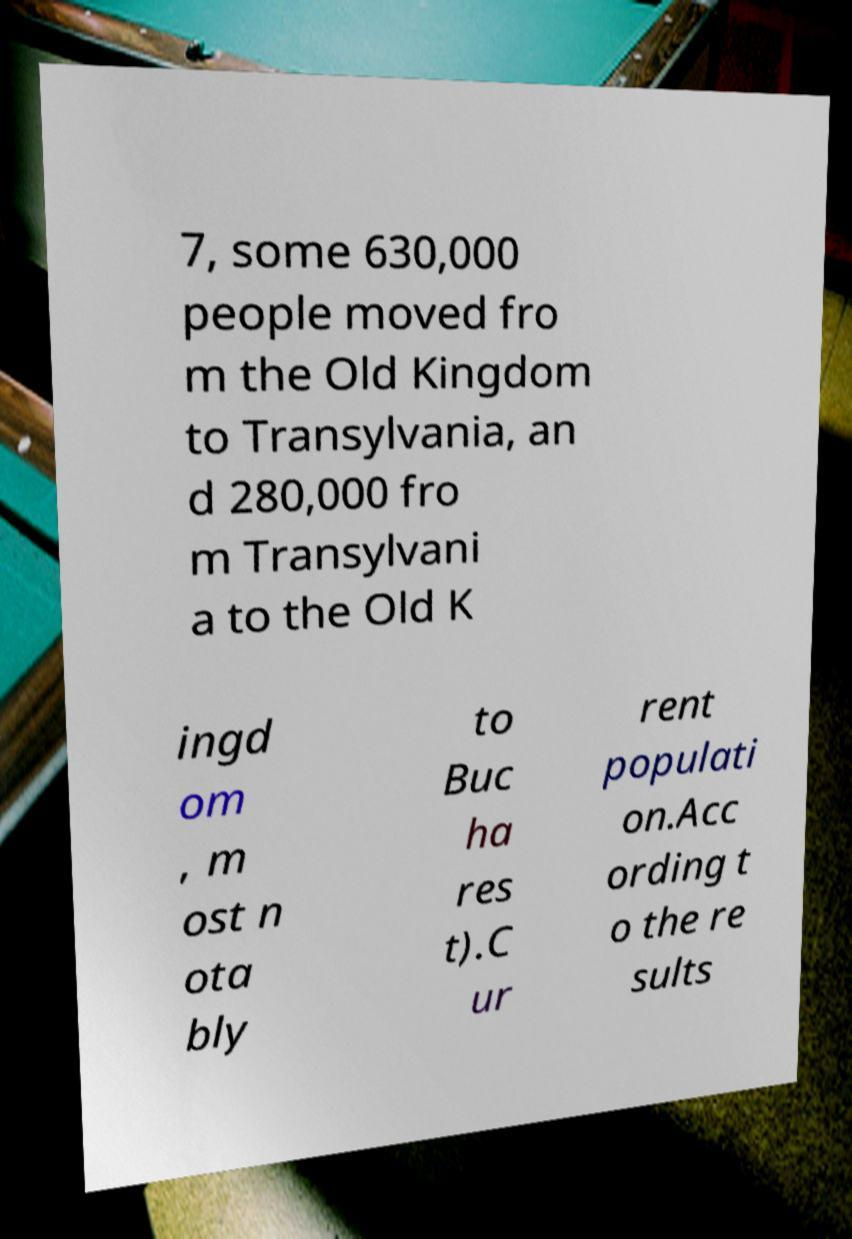Please read and relay the text visible in this image. What does it say? 7, some 630,000 people moved fro m the Old Kingdom to Transylvania, an d 280,000 fro m Transylvani a to the Old K ingd om , m ost n ota bly to Buc ha res t).C ur rent populati on.Acc ording t o the re sults 